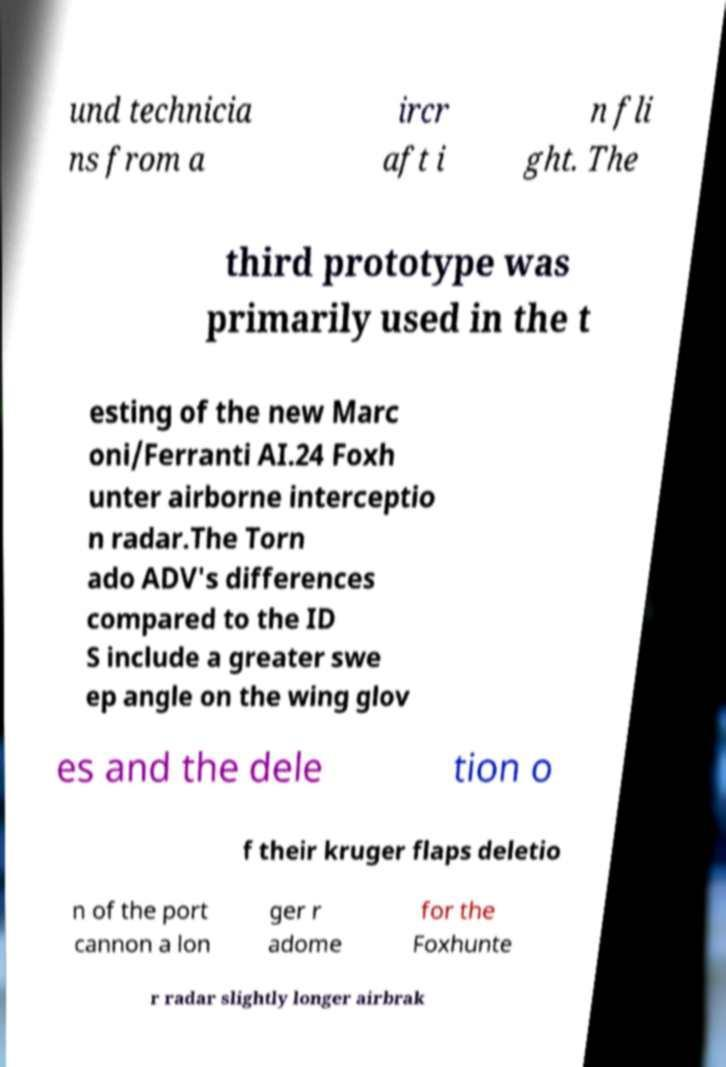Can you read and provide the text displayed in the image?This photo seems to have some interesting text. Can you extract and type it out for me? und technicia ns from a ircr aft i n fli ght. The third prototype was primarily used in the t esting of the new Marc oni/Ferranti AI.24 Foxh unter airborne interceptio n radar.The Torn ado ADV's differences compared to the ID S include a greater swe ep angle on the wing glov es and the dele tion o f their kruger flaps deletio n of the port cannon a lon ger r adome for the Foxhunte r radar slightly longer airbrak 